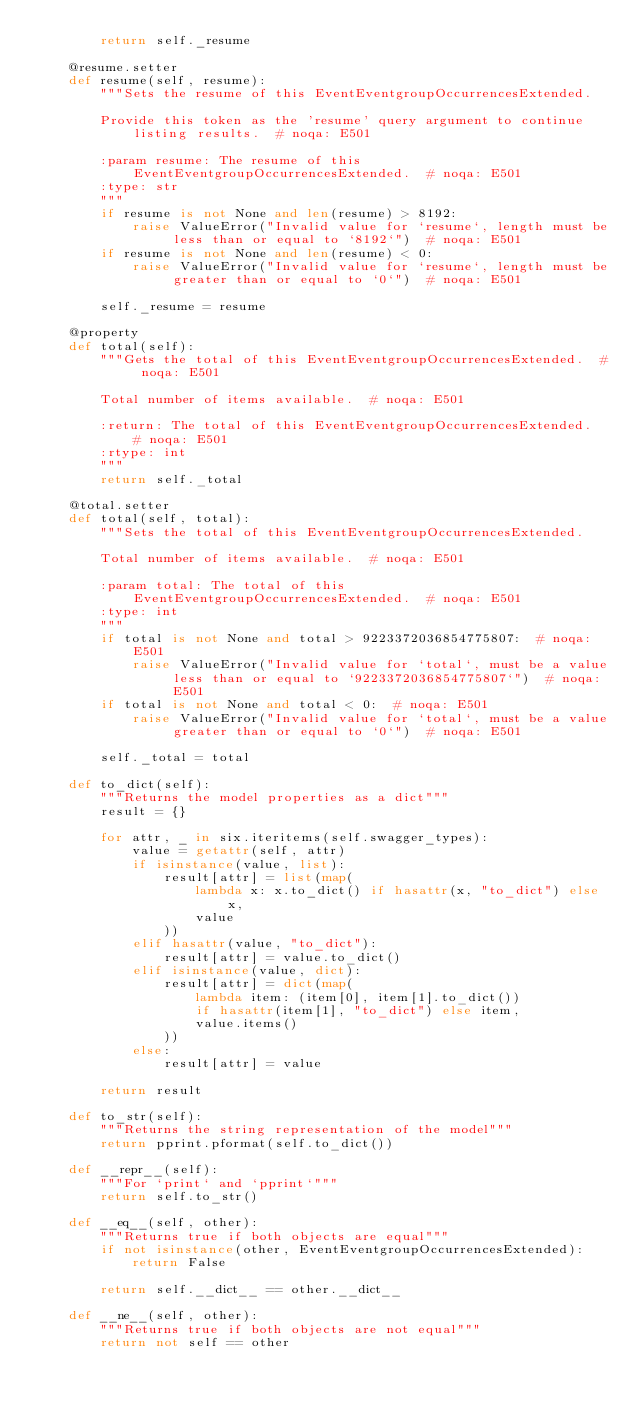Convert code to text. <code><loc_0><loc_0><loc_500><loc_500><_Python_>        return self._resume

    @resume.setter
    def resume(self, resume):
        """Sets the resume of this EventEventgroupOccurrencesExtended.

        Provide this token as the 'resume' query argument to continue listing results.  # noqa: E501

        :param resume: The resume of this EventEventgroupOccurrencesExtended.  # noqa: E501
        :type: str
        """
        if resume is not None and len(resume) > 8192:
            raise ValueError("Invalid value for `resume`, length must be less than or equal to `8192`")  # noqa: E501
        if resume is not None and len(resume) < 0:
            raise ValueError("Invalid value for `resume`, length must be greater than or equal to `0`")  # noqa: E501

        self._resume = resume

    @property
    def total(self):
        """Gets the total of this EventEventgroupOccurrencesExtended.  # noqa: E501

        Total number of items available.  # noqa: E501

        :return: The total of this EventEventgroupOccurrencesExtended.  # noqa: E501
        :rtype: int
        """
        return self._total

    @total.setter
    def total(self, total):
        """Sets the total of this EventEventgroupOccurrencesExtended.

        Total number of items available.  # noqa: E501

        :param total: The total of this EventEventgroupOccurrencesExtended.  # noqa: E501
        :type: int
        """
        if total is not None and total > 9223372036854775807:  # noqa: E501
            raise ValueError("Invalid value for `total`, must be a value less than or equal to `9223372036854775807`")  # noqa: E501
        if total is not None and total < 0:  # noqa: E501
            raise ValueError("Invalid value for `total`, must be a value greater than or equal to `0`")  # noqa: E501

        self._total = total

    def to_dict(self):
        """Returns the model properties as a dict"""
        result = {}

        for attr, _ in six.iteritems(self.swagger_types):
            value = getattr(self, attr)
            if isinstance(value, list):
                result[attr] = list(map(
                    lambda x: x.to_dict() if hasattr(x, "to_dict") else x,
                    value
                ))
            elif hasattr(value, "to_dict"):
                result[attr] = value.to_dict()
            elif isinstance(value, dict):
                result[attr] = dict(map(
                    lambda item: (item[0], item[1].to_dict())
                    if hasattr(item[1], "to_dict") else item,
                    value.items()
                ))
            else:
                result[attr] = value

        return result

    def to_str(self):
        """Returns the string representation of the model"""
        return pprint.pformat(self.to_dict())

    def __repr__(self):
        """For `print` and `pprint`"""
        return self.to_str()

    def __eq__(self, other):
        """Returns true if both objects are equal"""
        if not isinstance(other, EventEventgroupOccurrencesExtended):
            return False

        return self.__dict__ == other.__dict__

    def __ne__(self, other):
        """Returns true if both objects are not equal"""
        return not self == other
</code> 